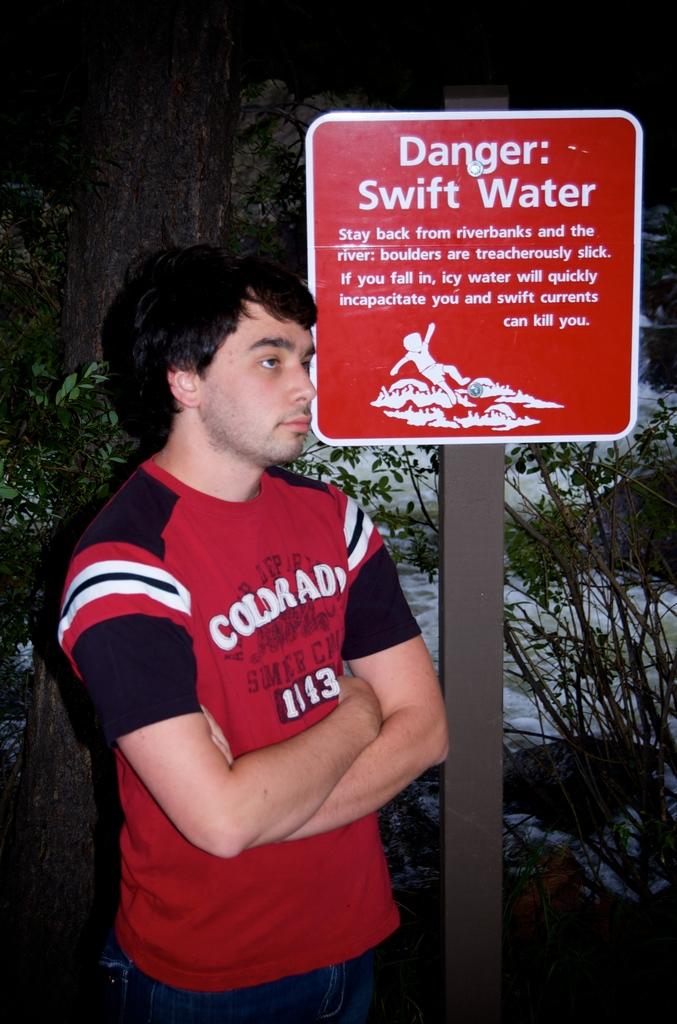What kind of danger is warned?
Offer a terse response. Swift water. 